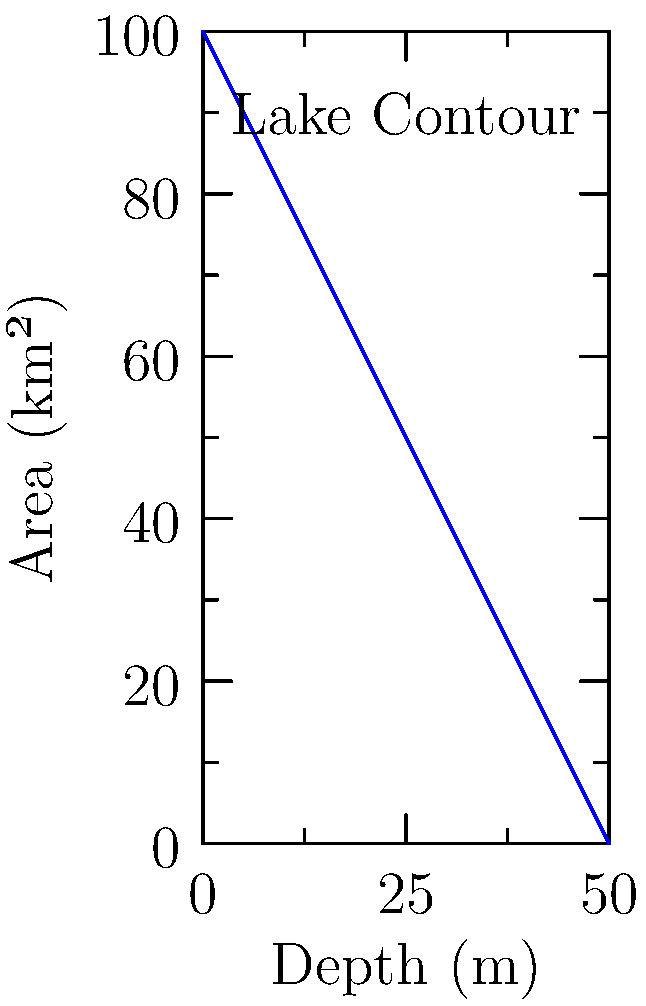As part of your hiking club's educational activities, you've led your students to a scenic lake. Using topographic contour lines, you've created a graph showing the surface area of the lake at different depths. Given the graph, calculate the volume of the lake in cubic kilometers. Assume the lake has a maximum depth of 50 meters and the contour lines are evenly spaced at 10-meter intervals. To calculate the volume of the lake, we can use the method of cylindrical shells or the washer method from calculus. Here's a step-by-step approach:

1) The graph shows the relationship between depth and surface area. We need to integrate this function to find the volume.

2) The volume can be approximated as the sum of thin cylindrical shells, each with a thickness of $\Delta x$ (in this case, 10 meters or 0.01 km).

3) The volume of each shell is approximately $V_i \approx 2\pi r_i h_i \Delta x$, where $r_i$ is the radius (derived from the area) and $h_i$ is the height of each shell.

4) We can simplify this to $V_i \approx A_i \Delta x$, where $A_i$ is the surface area at each depth.

5) The total volume is the sum of these shells: $V = \sum_{i=1}^n A_i \Delta x$

6) In the limit, this becomes the definite integral: $V = \int_0^{50} A(x) dx$

7) From the graph, we can approximate the function $A(x)$ as linear:
   $A(x) = 100 - 2x$ (km²), where $x$ is the depth in meters

8) Now we can solve the integral:
   $V = \int_0^{50} (100 - 2x) dx$
   $= [100x - x^2]_0^{50}$
   $= (5000 - 2500) - (0 - 0)$
   $= 2500$ km²⋅m

9) Converting to cubic kilometers:
   $V = 2500 \times 10^{-3} = 2.5$ km³

Therefore, the volume of the lake is approximately 2.5 cubic kilometers.
Answer: 2.5 km³ 